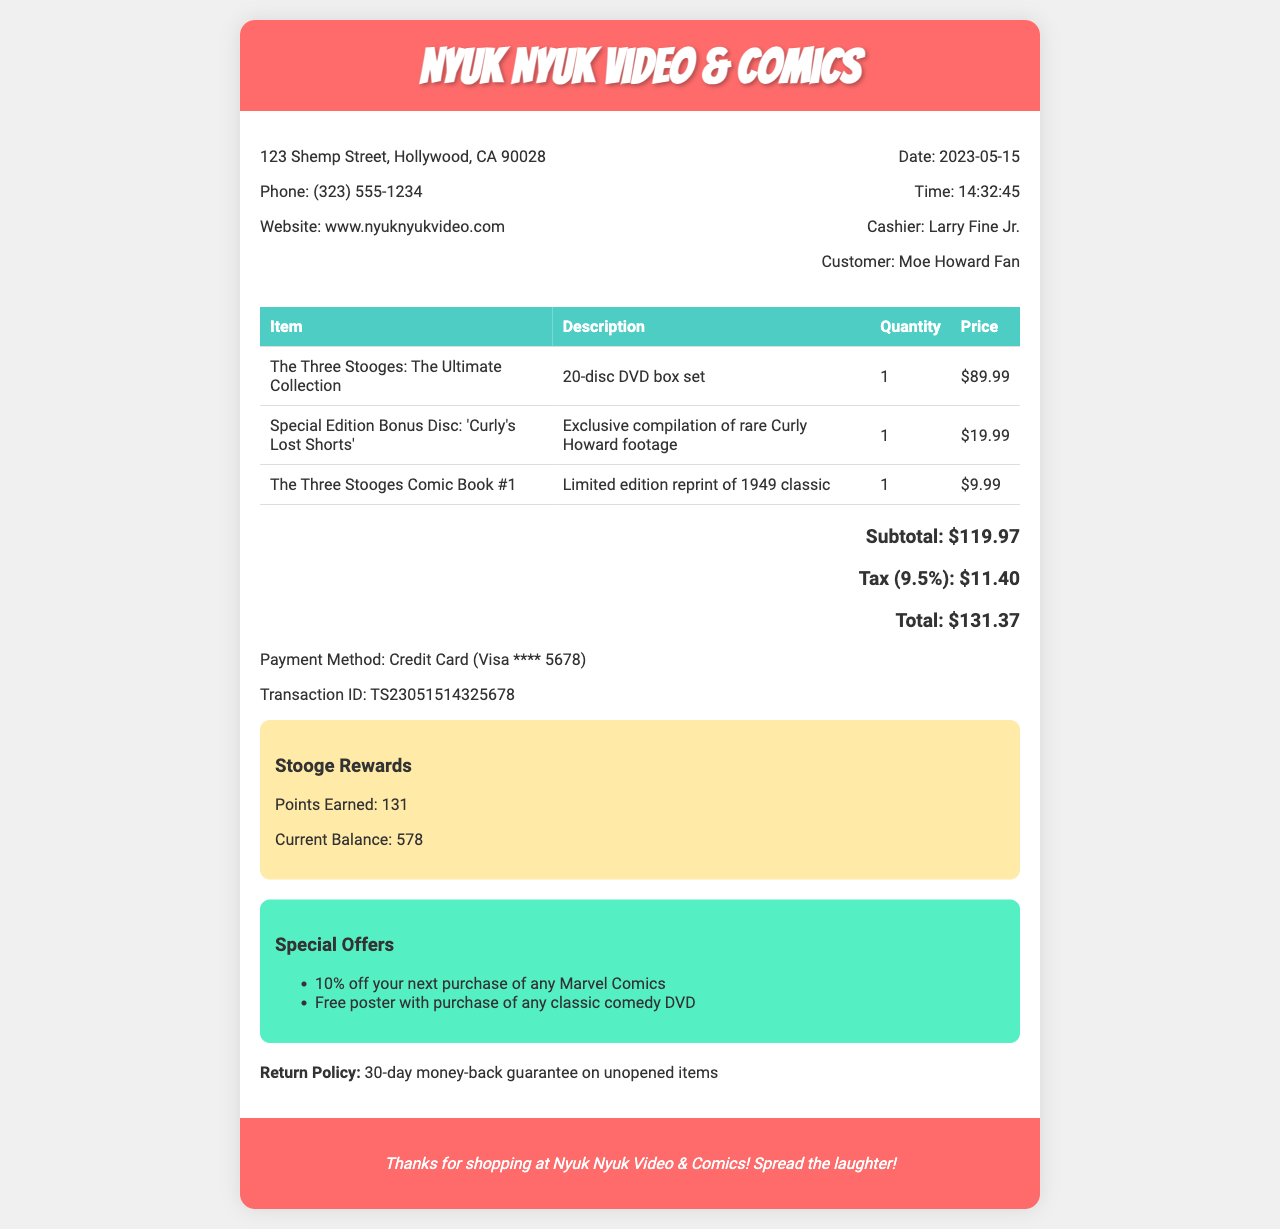What is the store name? The store name is prominently displayed at the top of the document.
Answer: Nyuk Nyuk Video & Comics What is the date of purchase? The date is provided in the document, indicating when the transaction occurred.
Answer: 2023-05-15 Who is the cashier? The cashier's name is mentioned near the transaction details.
Answer: Larry Fine Jr What is the subtotal amount? The subtotal amount is clearly listed in the pricing section of the receipt.
Answer: $119.97 What is the total cost of the purchase? The total is calculated after adding tax to the subtotal.
Answer: $131.37 How many points were earned in the loyalty program? The points earned are indicated in the loyalty program section of the receipt.
Answer: 131 What is the return policy? The return policy is stated at the bottom of the receipt for customer reference.
Answer: 30-day money-back guarantee on unopened items What is the price of the bonus disc? The price of the special edition bonus disc is specified in the items list.
Answer: $19.99 What special offer is included? The receipt lists special offers, providing promotional deals for customers.
Answer: 10% off your next purchase of any Marvel Comics 